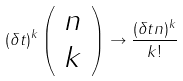<formula> <loc_0><loc_0><loc_500><loc_500>( \delta t ) ^ { k } \left ( \begin{array} { c } n \\ k \end{array} \right ) \rightarrow \frac { ( \delta t n ) ^ { k } } { k ! }</formula> 